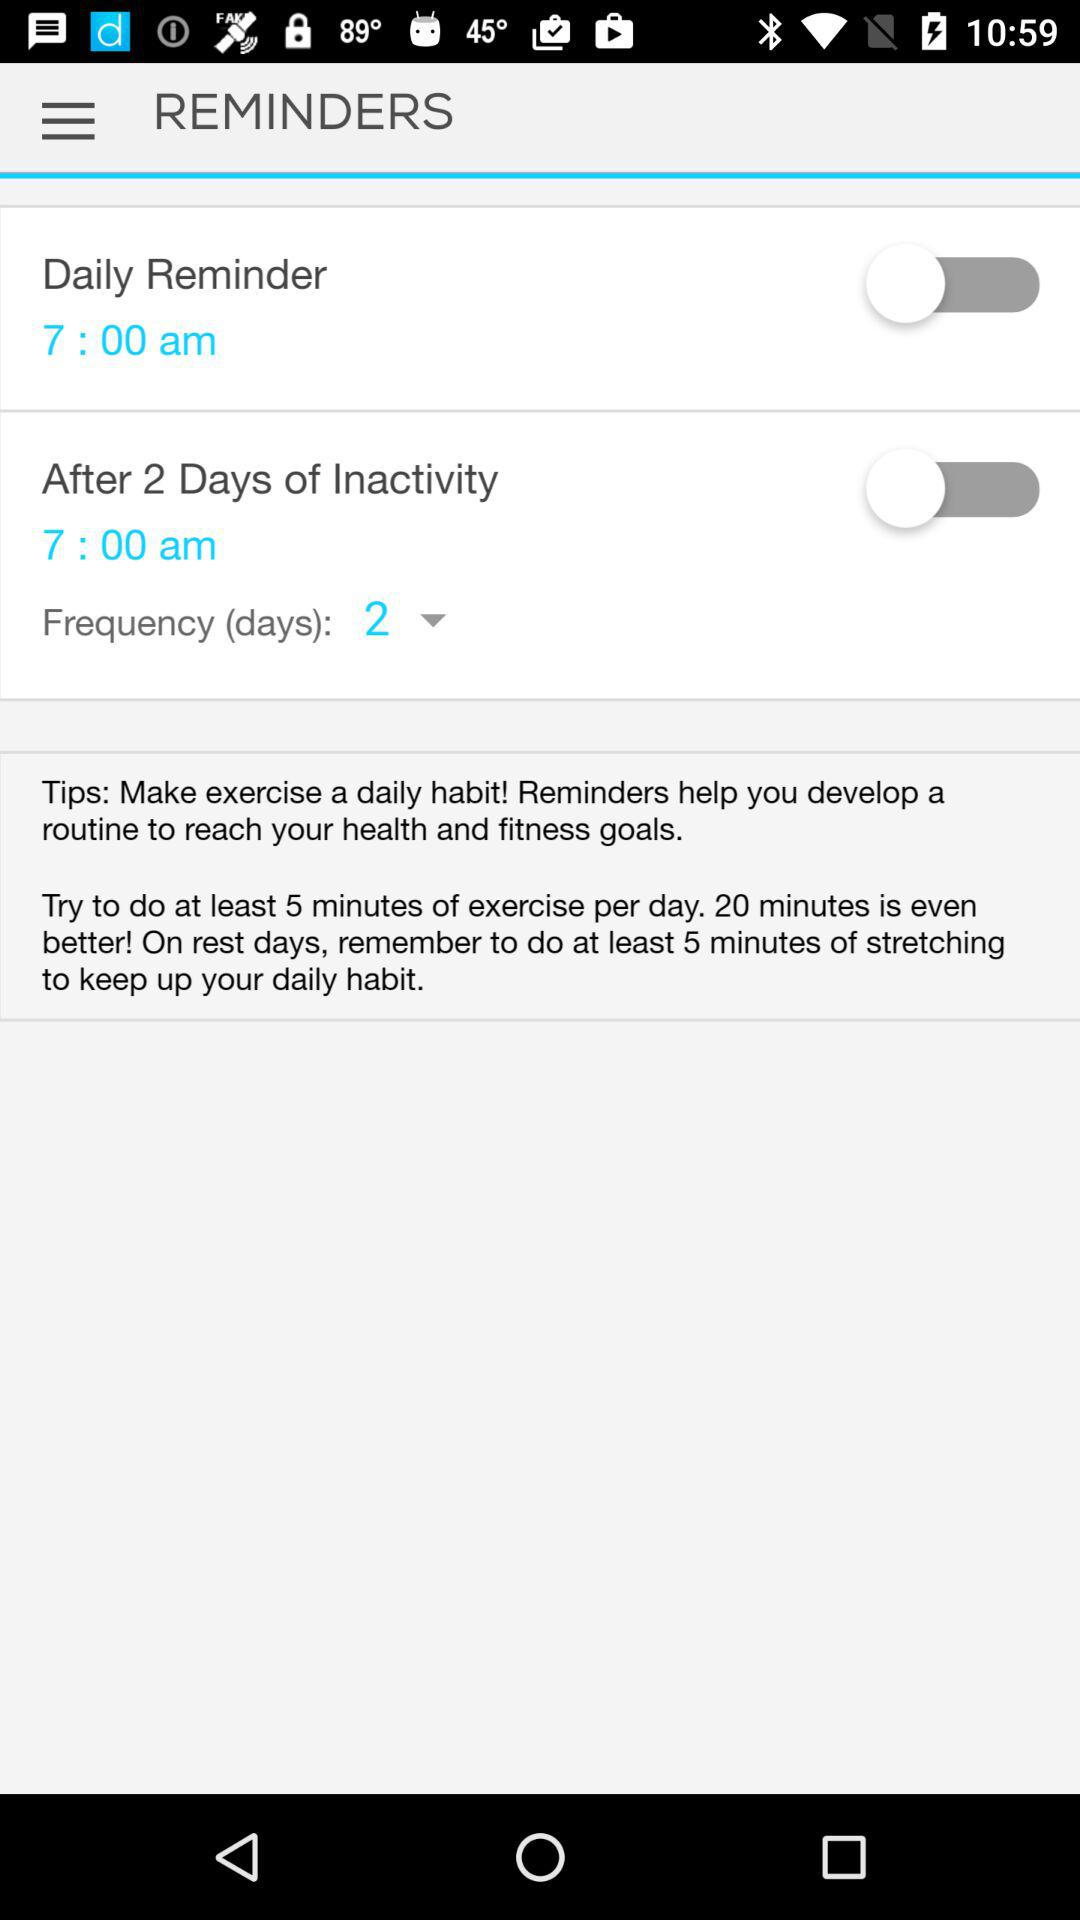How many reminders are set up?
Answer the question using a single word or phrase. 2 